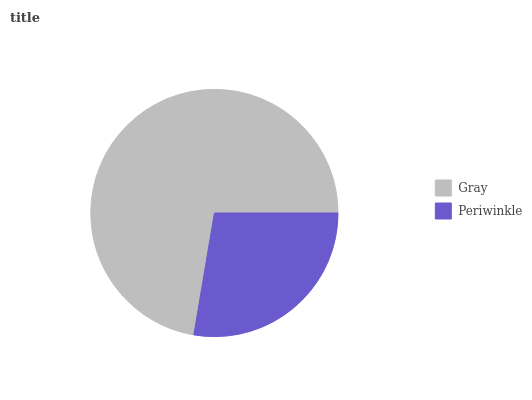Is Periwinkle the minimum?
Answer yes or no. Yes. Is Gray the maximum?
Answer yes or no. Yes. Is Periwinkle the maximum?
Answer yes or no. No. Is Gray greater than Periwinkle?
Answer yes or no. Yes. Is Periwinkle less than Gray?
Answer yes or no. Yes. Is Periwinkle greater than Gray?
Answer yes or no. No. Is Gray less than Periwinkle?
Answer yes or no. No. Is Gray the high median?
Answer yes or no. Yes. Is Periwinkle the low median?
Answer yes or no. Yes. Is Periwinkle the high median?
Answer yes or no. No. Is Gray the low median?
Answer yes or no. No. 